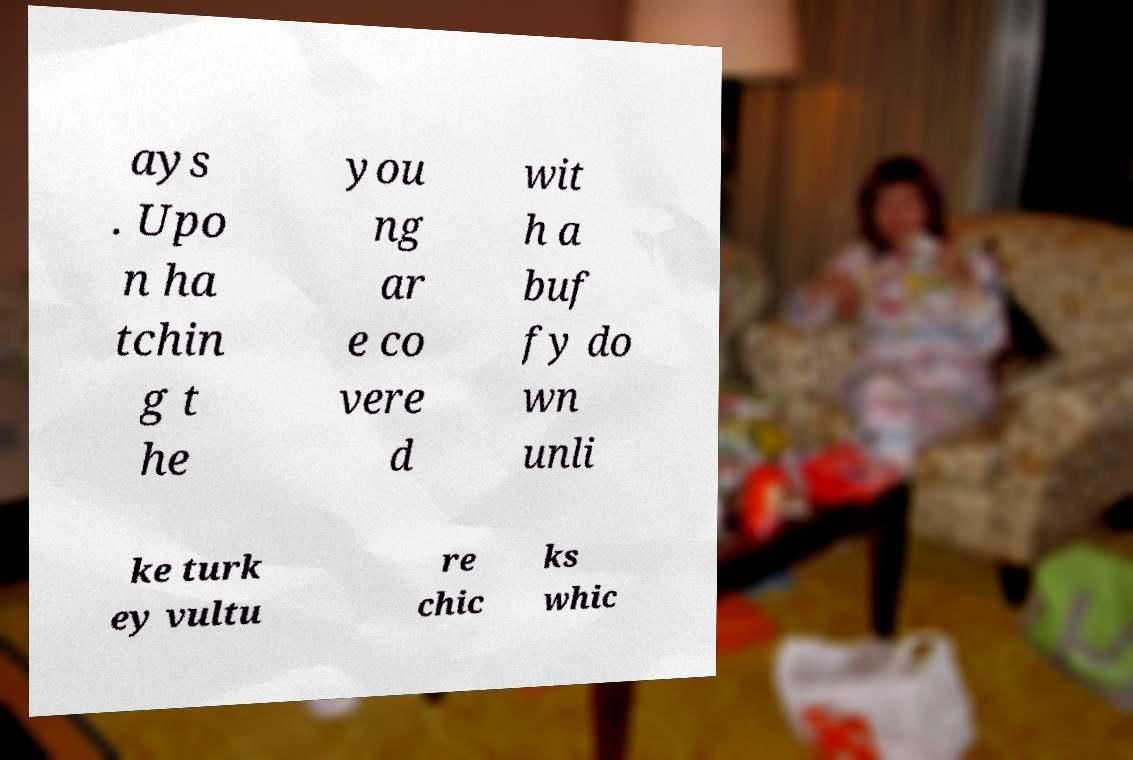Can you accurately transcribe the text from the provided image for me? ays . Upo n ha tchin g t he you ng ar e co vere d wit h a buf fy do wn unli ke turk ey vultu re chic ks whic 